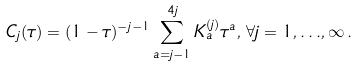<formula> <loc_0><loc_0><loc_500><loc_500>C _ { j } ( \tau ) = ( 1 - \tau ) ^ { - j - 1 } \sum _ { a = j - 1 } ^ { 4 j } K _ { a } ^ { ( j ) } \tau ^ { a } , \, \forall j = 1 , { \dots } , \infty \, .</formula> 